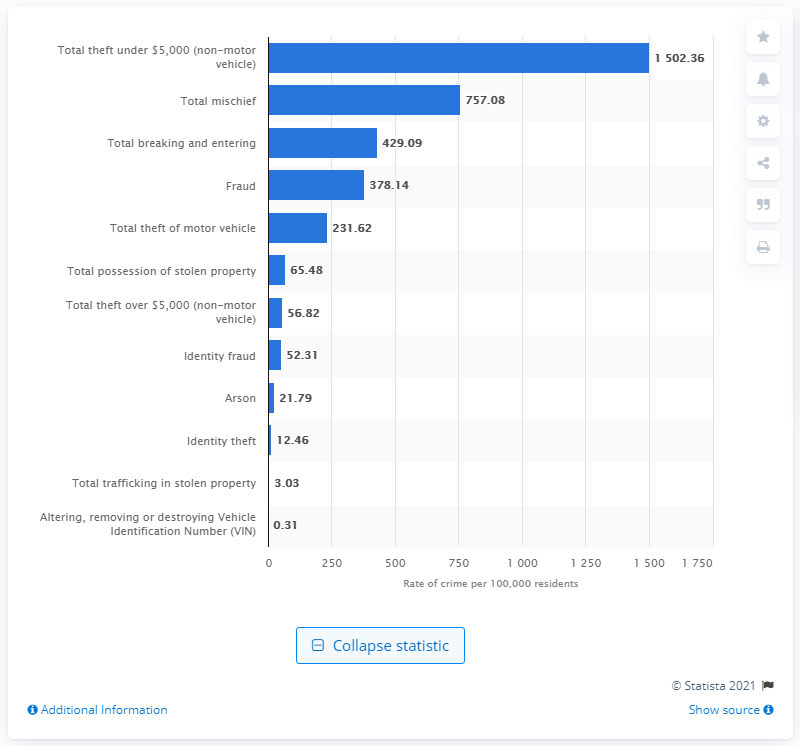Can you compare the rates of 'Fraud' and 'Arson' in 2019 in Canada? Certainly, in 2019, Canada reported a rate of 378.14 incidents of 'Fraud' per 100,000 residents, which is significantly higher than the rate of 'Arson' incidents, which stood at 21.79 per 100,000 residents. 